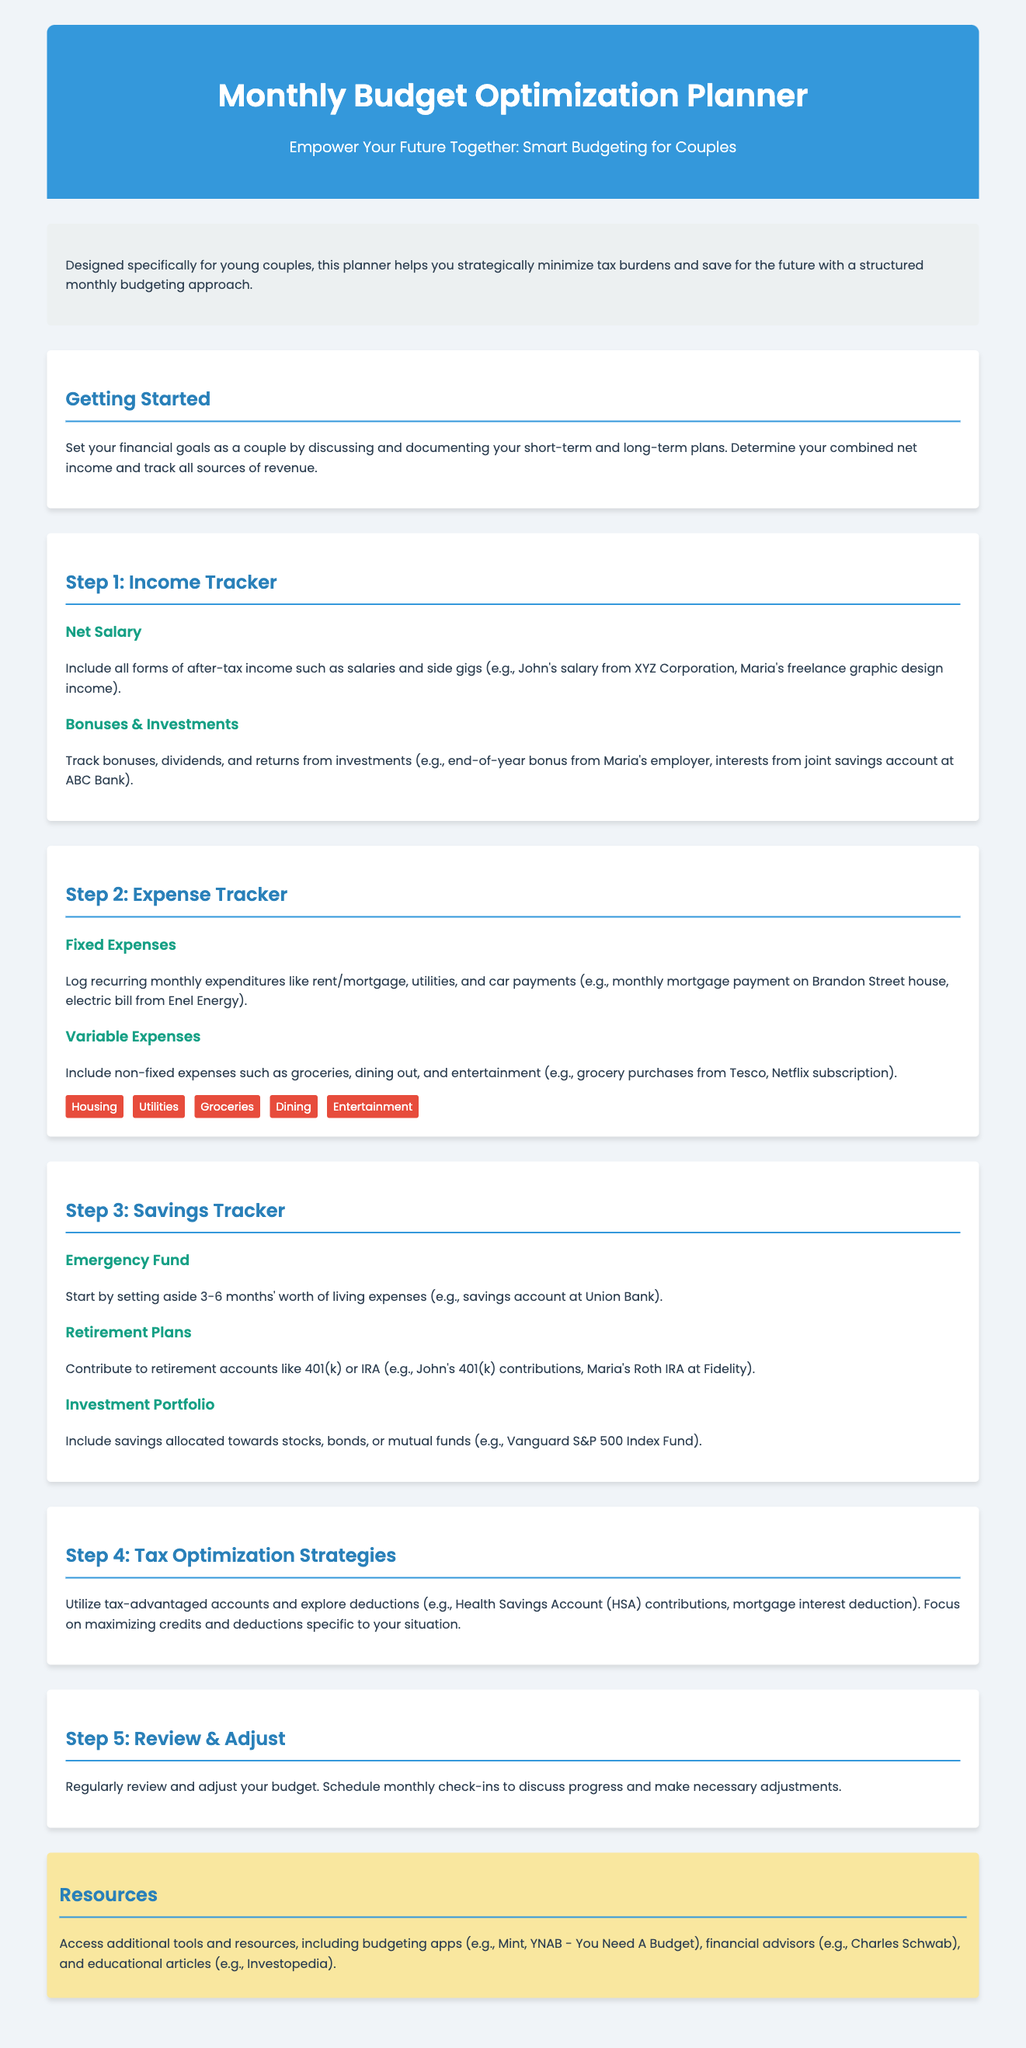What is the target audience for the planner? The planner is designed specifically for young couples who want to manage their finances.
Answer: young couples What are the two main types of expenses tracked? The document mentions fixed and variable expenses as the main types of expenses to be tracked.
Answer: Fixed and variable How many months' worth of living expenses should you save for an emergency fund? The planner suggests saving 3-6 months' worth of living expenses as an emergency fund.
Answer: 3-6 months What type of retirement accounts are mentioned in the planner? The planner specifically mentions 401(k) and IRA as types of retirement accounts.
Answer: 401(k) and IRA What is the first step in the budgeting process? The first step involves setting financial goals and determining combined net income.
Answer: Setting financial goals Which financial tools are recommended for budgeting? The document lists budgeting apps like Mint and YNAB as recommended tools.
Answer: Mint, YNAB What is suggested for tax optimization strategies? The planner suggests utilizing tax-advantaged accounts and exploring deductions for tax optimization.
Answer: Tax-advantaged accounts How often should you review and adjust your budget? The planner recommends scheduling monthly check-ins to review and adjust the budget.
Answer: Monthly What is included in the section on Savings Tracker? The Savings Tracker section includes Emergency Fund, Retirement Plans, and Investment Portfolio.
Answer: Emergency Fund, Retirement Plans, Investment Portfolio 